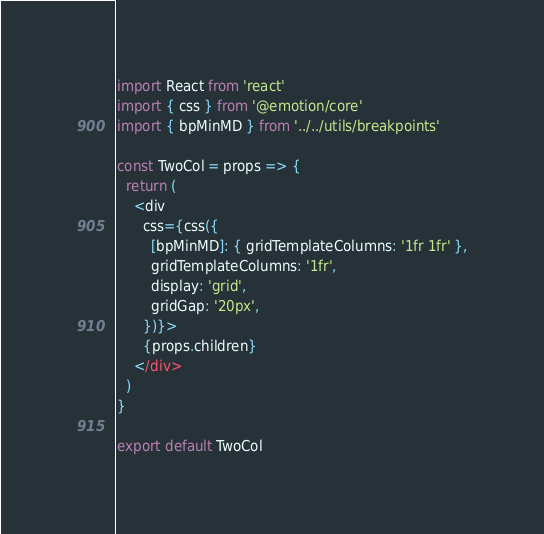<code> <loc_0><loc_0><loc_500><loc_500><_JavaScript_>import React from 'react'
import { css } from '@emotion/core'
import { bpMinMD } from '../../utils/breakpoints'

const TwoCol = props => {
  return (
    <div
      css={css({
        [bpMinMD]: { gridTemplateColumns: '1fr 1fr' },
        gridTemplateColumns: '1fr',
        display: 'grid',
        gridGap: '20px',
      })}>
      {props.children}
    </div>
  )
}

export default TwoCol
</code> 